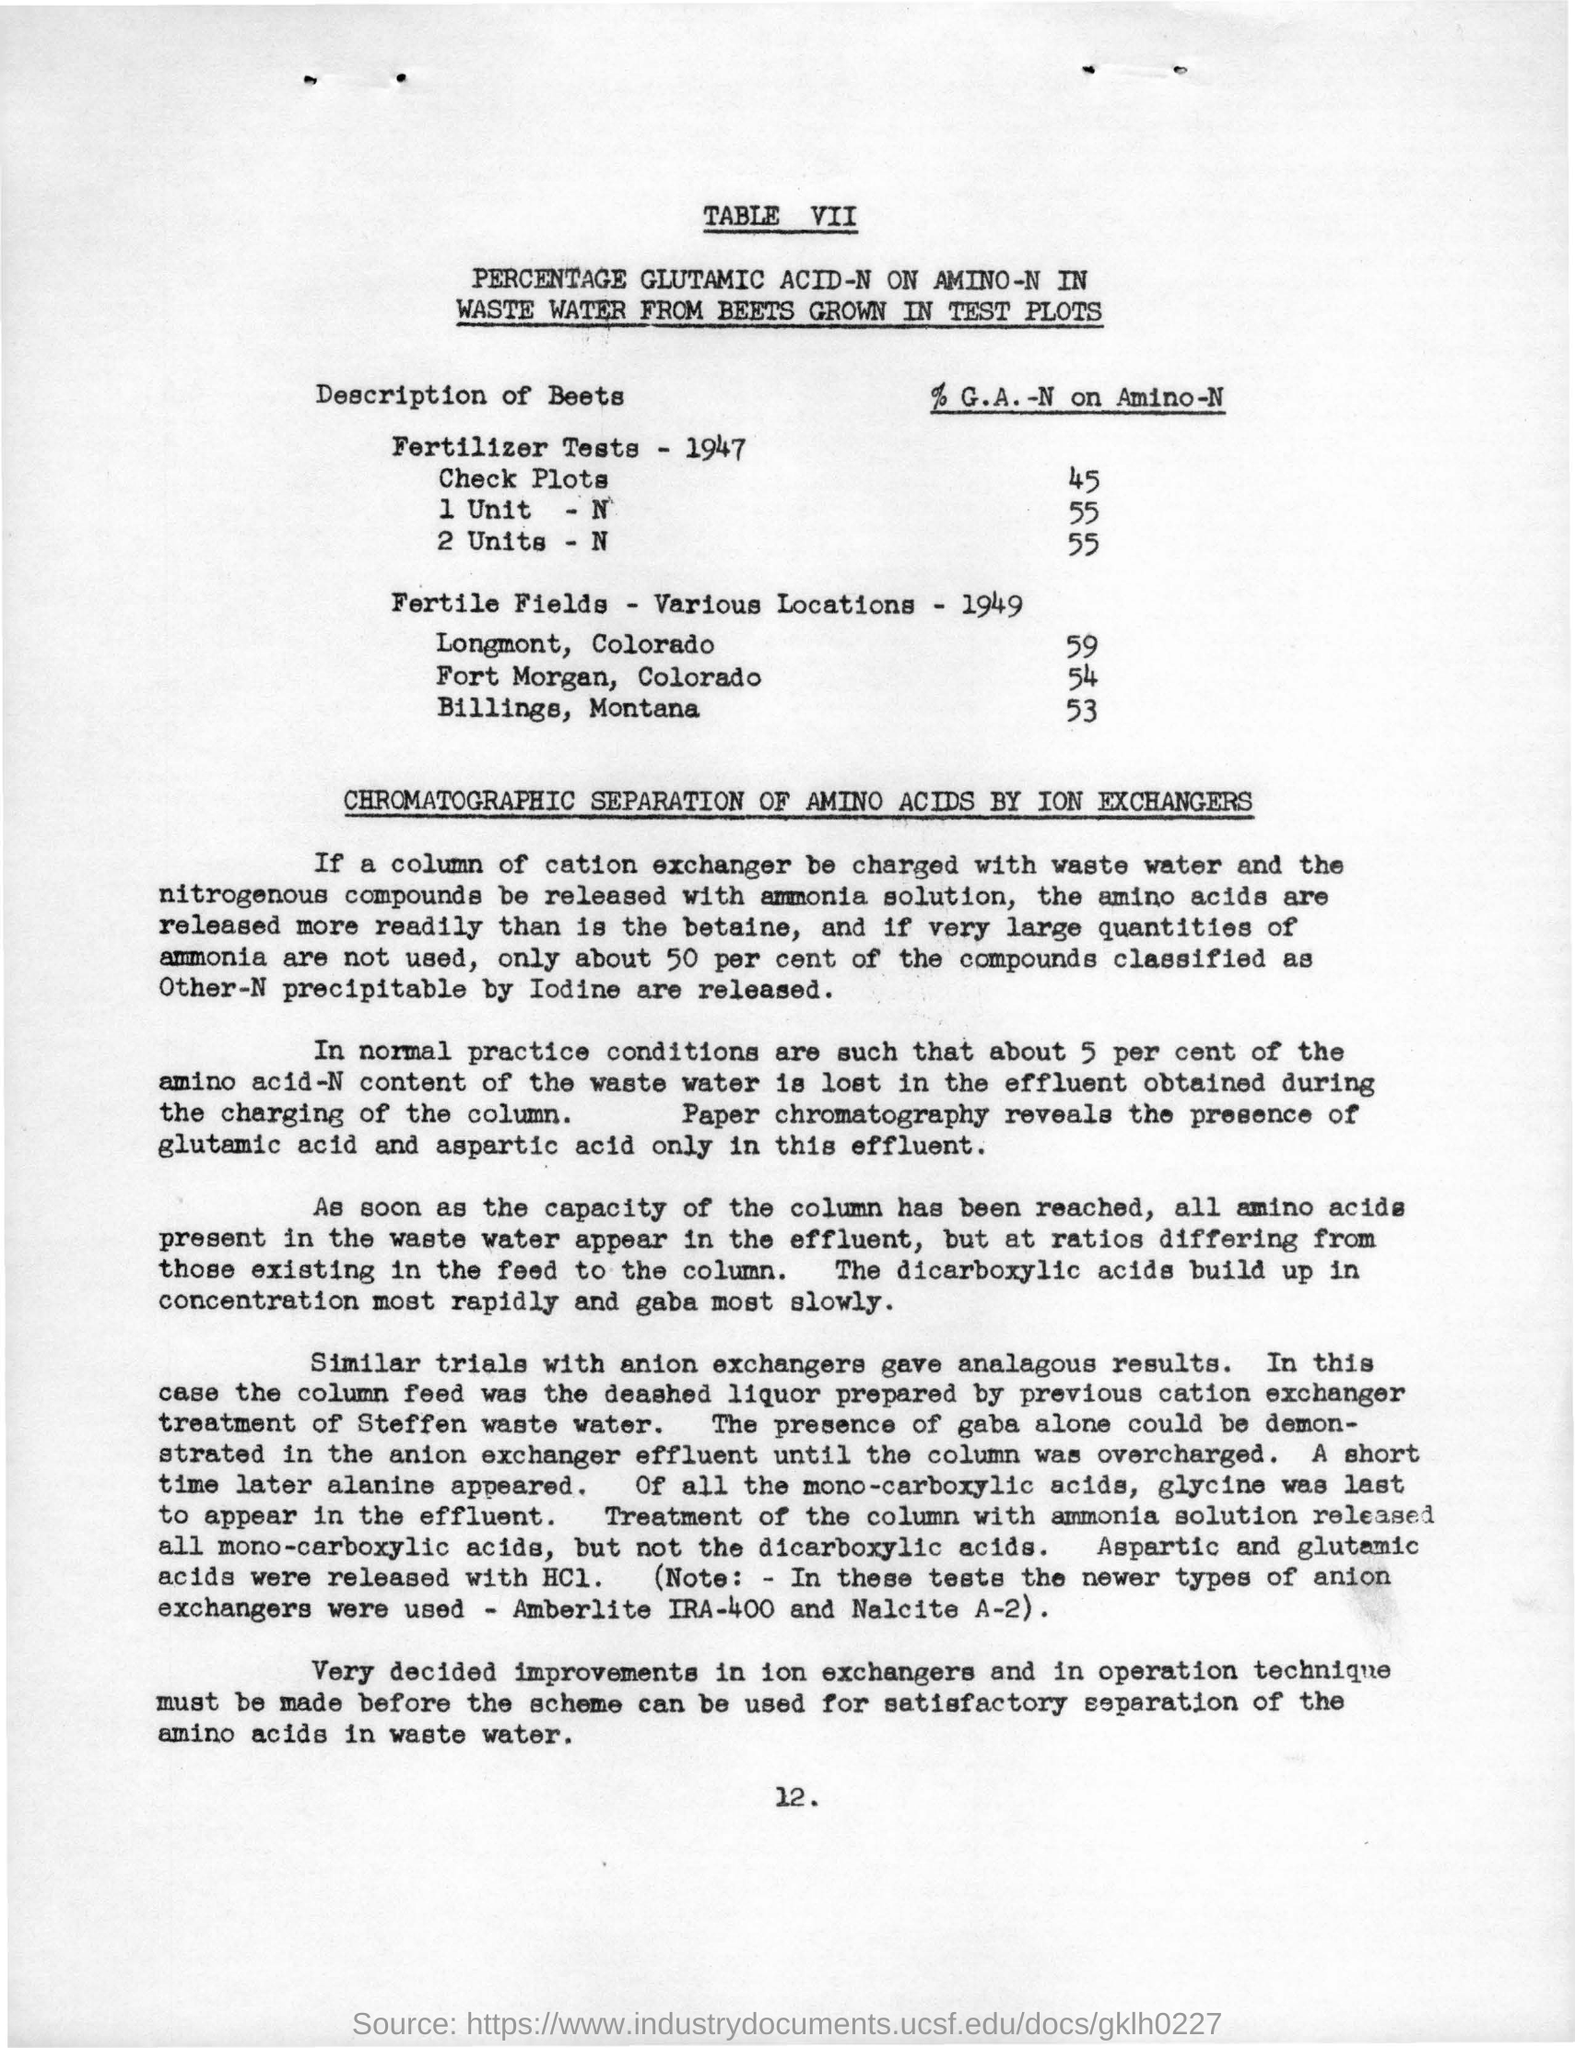WHAT IS THE % G.A -N on amino -N  for 2 units -N ?
Ensure brevity in your answer.  55. How many fertile fields are located in longmont ,colorado ?
Offer a very short reply. 59. In which location 53 fertile fields are located ?
Provide a succinct answer. Billings, Montana. How many fertile fields are located in fort morgan ,colorado ?
Offer a very short reply. 54. Chromatographic separation of amino acids is done by ?
Offer a very short reply. ION EXCHANGERS. 